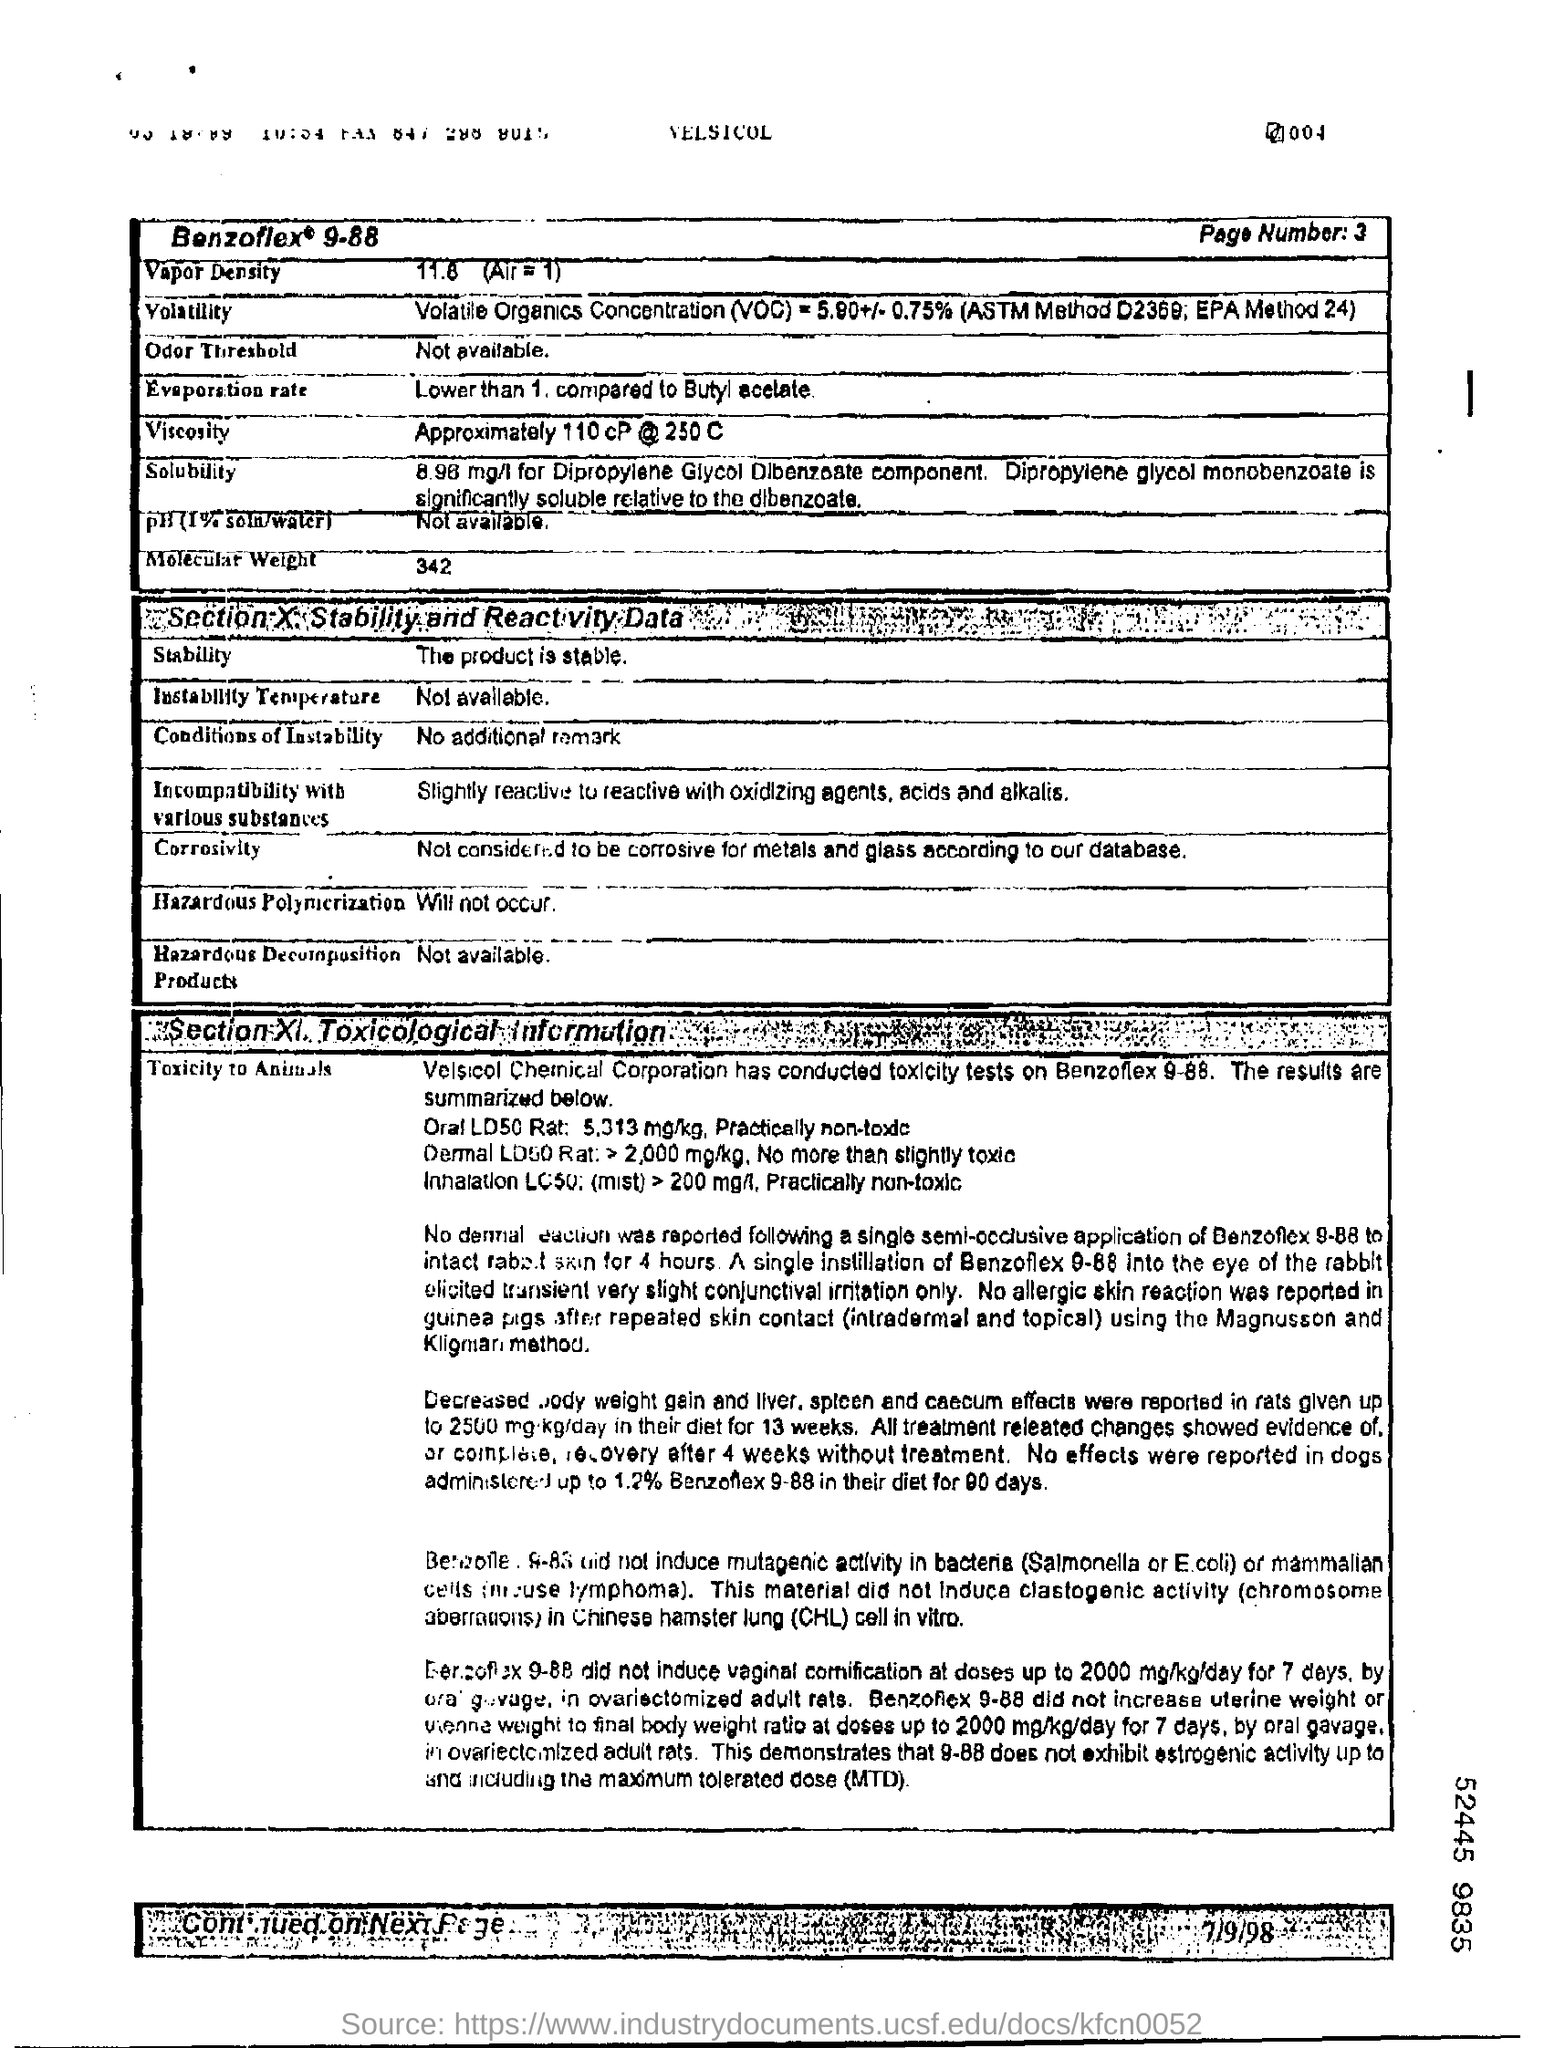What is the vapor density?
Ensure brevity in your answer.  11.8. What is the molecular weight?
Your response must be concise. 342. What is said about hazardous polymerization?
Provide a short and direct response. Will not occur. 